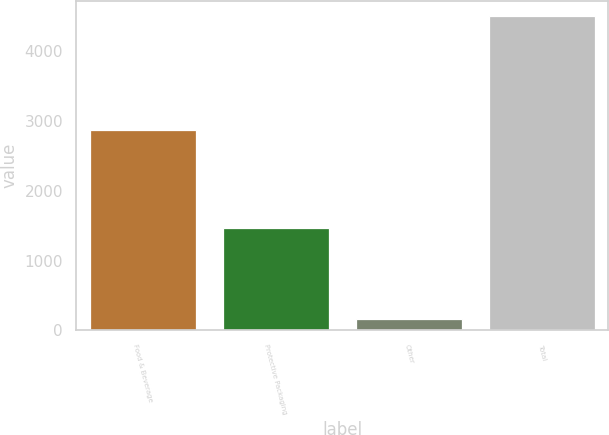<chart> <loc_0><loc_0><loc_500><loc_500><bar_chart><fcel>Food & Beverage<fcel>Protective Packaging<fcel>Other<fcel>Total<nl><fcel>2858.5<fcel>1469.9<fcel>161.7<fcel>4490.1<nl></chart> 